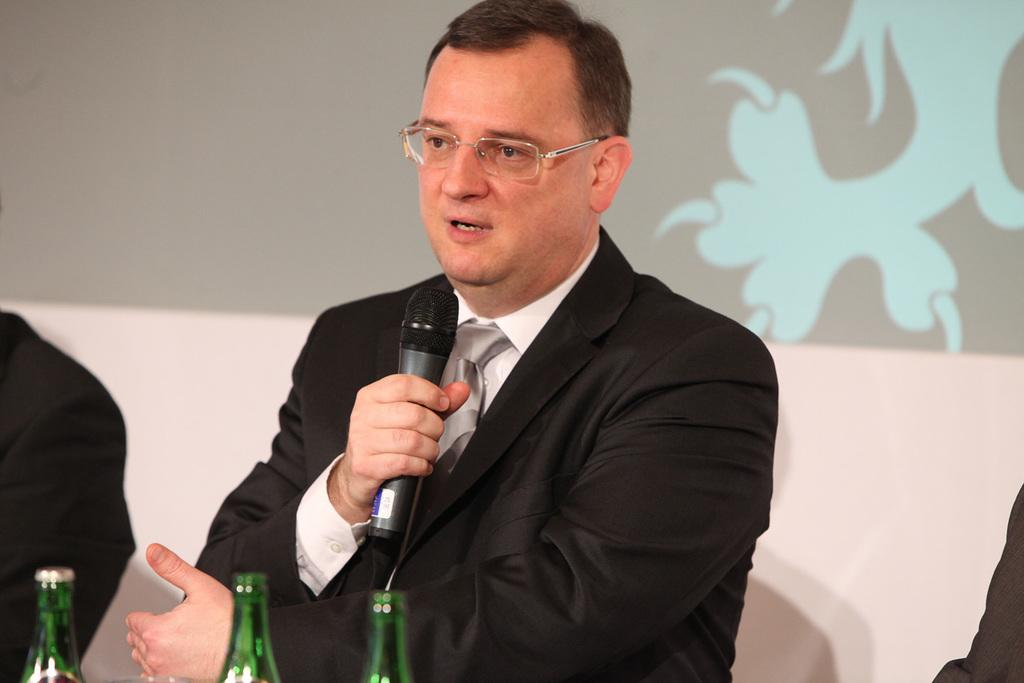What is the main subject of the image? There is a person in the image. What is the person wearing? The person is wearing a black dress. What is the person holding? The person is holding a mic. What is the person doing? The person is speaking. What accessory is the person wearing? The person is wearing spectacles. What objects are in front of the person? There are three green bottles in front of the person. What type of duck can be seen holding a whip in the image? There is no duck or whip present in the image. Can you tell me the flavor of the berries on the person's plate? There are no berries or plates present in the image. 